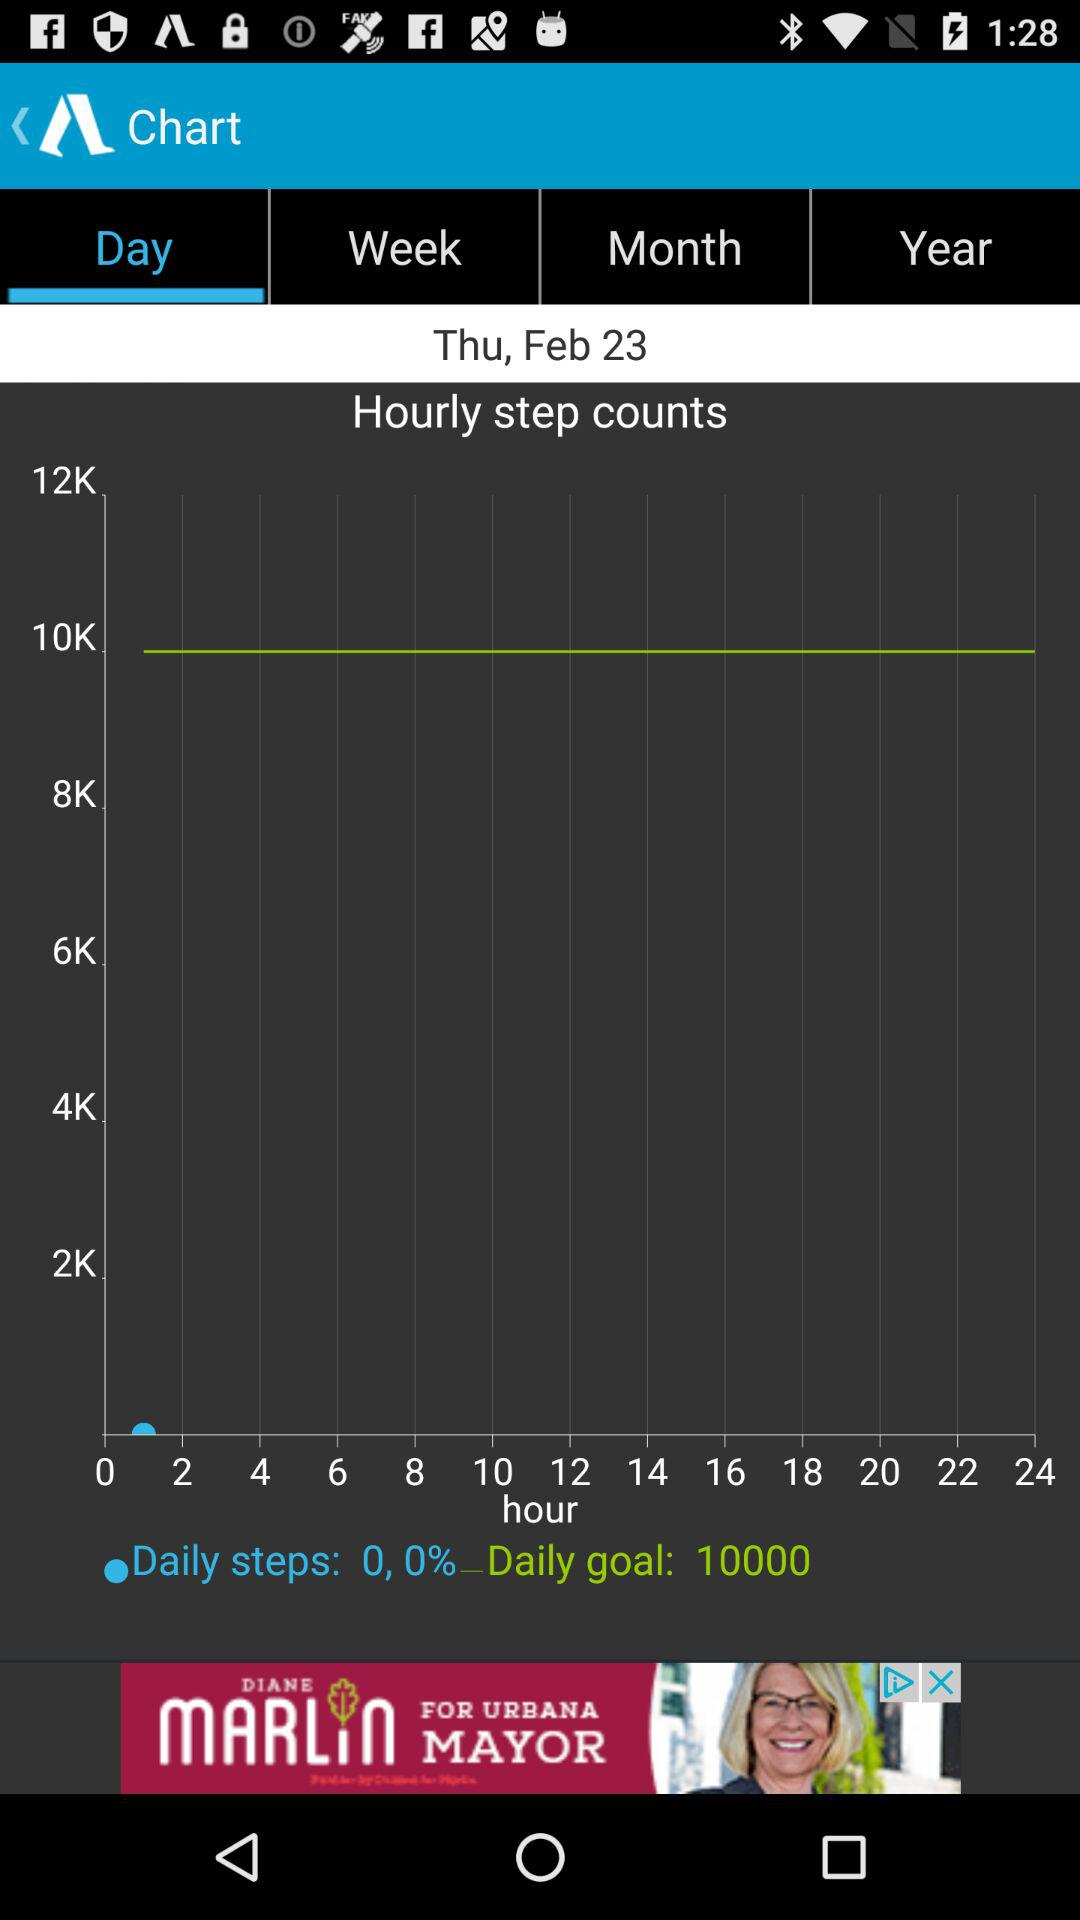What is the daily goal count? The daily goal count is 10,000. 